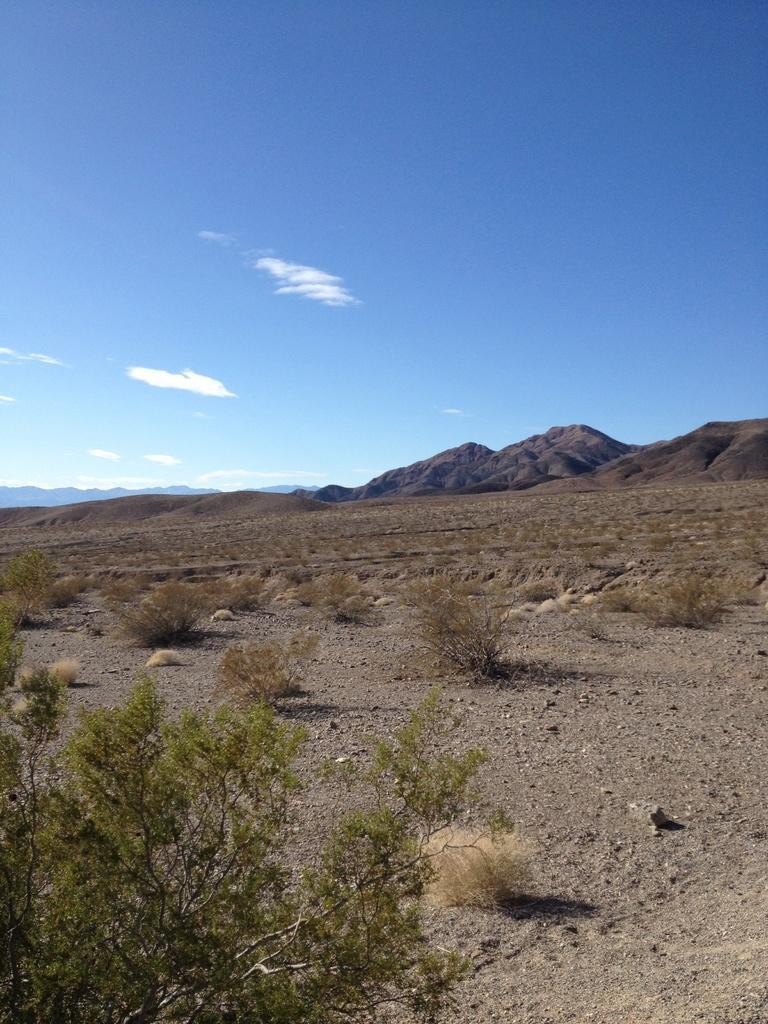In one or two sentences, can you explain what this image depicts? In this image there is a land, in that land there are plants, in the background there are mountains and the sky. 